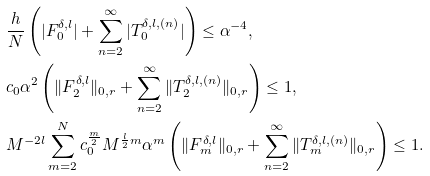<formula> <loc_0><loc_0><loc_500><loc_500>& \frac { h } { N } \left ( | F ^ { \delta , l } _ { 0 } | + \sum _ { n = 2 } ^ { \infty } | T _ { 0 } ^ { \delta , l , ( n ) } | \right ) \leq \alpha ^ { - 4 } , \\ & c _ { 0 } \alpha ^ { 2 } \left ( \| F _ { 2 } ^ { \delta , l } \| _ { 0 , r } + \sum _ { n = 2 } ^ { \infty } \| T _ { 2 } ^ { \delta , l , ( n ) } \| _ { 0 , r } \right ) \leq 1 , \\ & M ^ { - 2 l } \sum _ { m = 2 } ^ { N } c _ { 0 } ^ { \frac { m } { 2 } } M ^ { \frac { l } { 2 } m } \alpha ^ { m } \left ( \| F _ { m } ^ { \delta , l } \| _ { 0 , r } + \sum _ { n = 2 } ^ { \infty } \| T _ { m } ^ { \delta , l , ( n ) } \| _ { 0 , r } \right ) \leq 1 .</formula> 